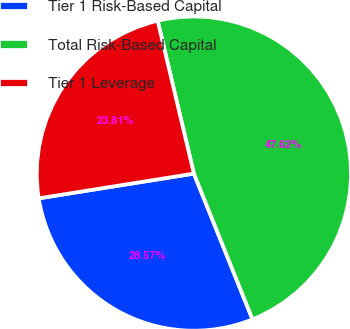Convert chart to OTSL. <chart><loc_0><loc_0><loc_500><loc_500><pie_chart><fcel>Tier 1 Risk-Based Capital<fcel>Total Risk-Based Capital<fcel>Tier 1 Leverage<nl><fcel>28.57%<fcel>47.62%<fcel>23.81%<nl></chart> 